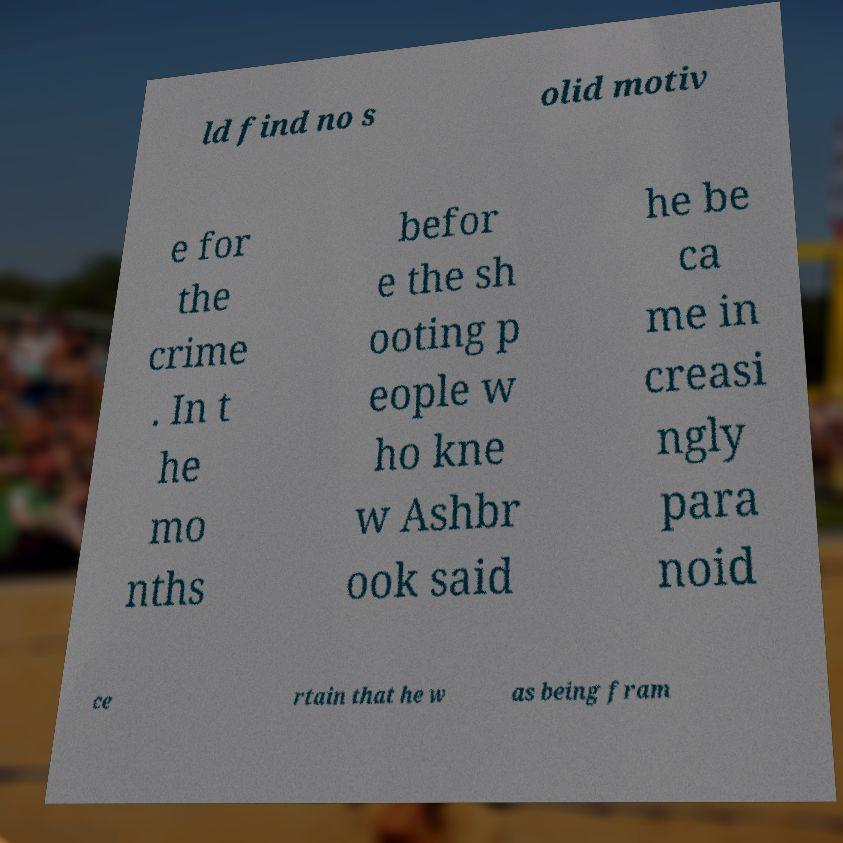Please identify and transcribe the text found in this image. ld find no s olid motiv e for the crime . In t he mo nths befor e the sh ooting p eople w ho kne w Ashbr ook said he be ca me in creasi ngly para noid ce rtain that he w as being fram 